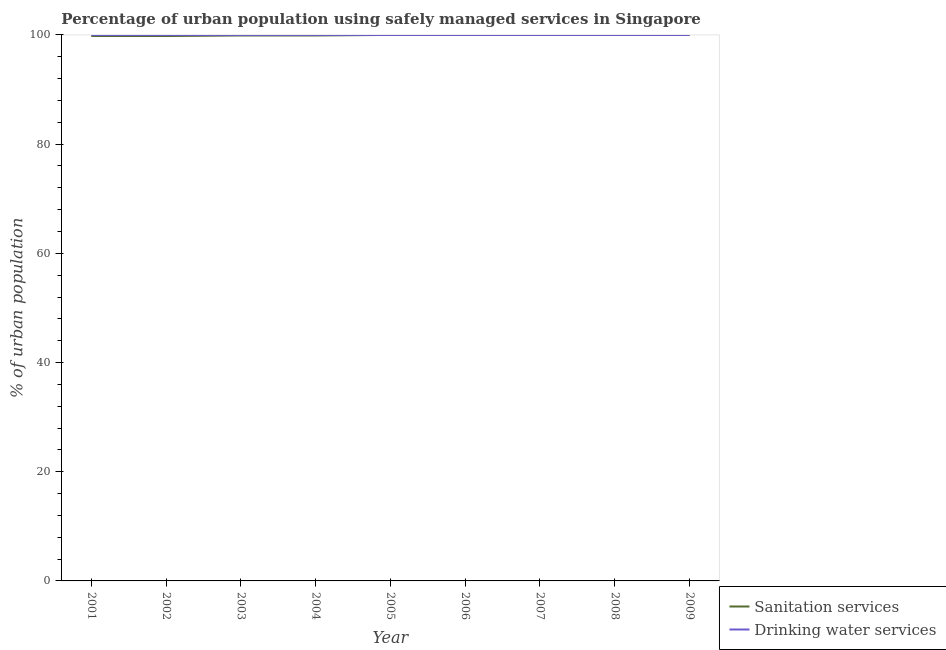How many different coloured lines are there?
Give a very brief answer. 2. Is the number of lines equal to the number of legend labels?
Offer a terse response. Yes. What is the percentage of urban population who used drinking water services in 2001?
Provide a short and direct response. 100. Across all years, what is the maximum percentage of urban population who used drinking water services?
Your answer should be very brief. 100. Across all years, what is the minimum percentage of urban population who used drinking water services?
Keep it short and to the point. 100. What is the total percentage of urban population who used sanitation services in the graph?
Provide a short and direct response. 899.4. What is the difference between the percentage of urban population who used sanitation services in 2004 and that in 2005?
Make the answer very short. -0.1. What is the difference between the percentage of urban population who used drinking water services in 2002 and the percentage of urban population who used sanitation services in 2006?
Keep it short and to the point. 0. What is the average percentage of urban population who used sanitation services per year?
Ensure brevity in your answer.  99.93. In the year 2001, what is the difference between the percentage of urban population who used drinking water services and percentage of urban population who used sanitation services?
Provide a succinct answer. 0.2. In how many years, is the percentage of urban population who used sanitation services greater than 8 %?
Your answer should be very brief. 9. Is the difference between the percentage of urban population who used drinking water services in 2006 and 2009 greater than the difference between the percentage of urban population who used sanitation services in 2006 and 2009?
Offer a terse response. No. What is the difference between the highest and the second highest percentage of urban population who used sanitation services?
Keep it short and to the point. 0. What is the difference between the highest and the lowest percentage of urban population who used sanitation services?
Keep it short and to the point. 0.2. In how many years, is the percentage of urban population who used drinking water services greater than the average percentage of urban population who used drinking water services taken over all years?
Your answer should be compact. 0. Is the sum of the percentage of urban population who used drinking water services in 2004 and 2009 greater than the maximum percentage of urban population who used sanitation services across all years?
Your answer should be very brief. Yes. Does the percentage of urban population who used sanitation services monotonically increase over the years?
Your answer should be very brief. No. Is the percentage of urban population who used drinking water services strictly greater than the percentage of urban population who used sanitation services over the years?
Your answer should be very brief. No. Is the percentage of urban population who used drinking water services strictly less than the percentage of urban population who used sanitation services over the years?
Keep it short and to the point. No. How many years are there in the graph?
Make the answer very short. 9. Are the values on the major ticks of Y-axis written in scientific E-notation?
Provide a succinct answer. No. Does the graph contain any zero values?
Provide a succinct answer. No. What is the title of the graph?
Offer a very short reply. Percentage of urban population using safely managed services in Singapore. What is the label or title of the Y-axis?
Your answer should be compact. % of urban population. What is the % of urban population in Sanitation services in 2001?
Your answer should be very brief. 99.8. What is the % of urban population of Drinking water services in 2001?
Your response must be concise. 100. What is the % of urban population of Sanitation services in 2002?
Your answer should be compact. 99.8. What is the % of urban population in Sanitation services in 2003?
Your answer should be very brief. 99.9. What is the % of urban population of Drinking water services in 2003?
Ensure brevity in your answer.  100. What is the % of urban population of Sanitation services in 2004?
Offer a terse response. 99.9. What is the % of urban population of Drinking water services in 2004?
Offer a terse response. 100. What is the % of urban population of Sanitation services in 2005?
Provide a short and direct response. 100. What is the % of urban population in Drinking water services in 2005?
Give a very brief answer. 100. What is the % of urban population of Sanitation services in 2006?
Give a very brief answer. 100. What is the % of urban population of Drinking water services in 2006?
Keep it short and to the point. 100. What is the % of urban population of Sanitation services in 2007?
Give a very brief answer. 100. What is the % of urban population of Drinking water services in 2007?
Ensure brevity in your answer.  100. What is the % of urban population in Sanitation services in 2008?
Keep it short and to the point. 100. What is the % of urban population in Drinking water services in 2008?
Offer a very short reply. 100. What is the % of urban population of Sanitation services in 2009?
Ensure brevity in your answer.  100. Across all years, what is the minimum % of urban population of Sanitation services?
Offer a terse response. 99.8. Across all years, what is the minimum % of urban population in Drinking water services?
Make the answer very short. 100. What is the total % of urban population of Sanitation services in the graph?
Your response must be concise. 899.4. What is the total % of urban population of Drinking water services in the graph?
Keep it short and to the point. 900. What is the difference between the % of urban population of Drinking water services in 2001 and that in 2002?
Your answer should be very brief. 0. What is the difference between the % of urban population in Sanitation services in 2001 and that in 2003?
Provide a succinct answer. -0.1. What is the difference between the % of urban population in Sanitation services in 2001 and that in 2006?
Ensure brevity in your answer.  -0.2. What is the difference between the % of urban population of Sanitation services in 2001 and that in 2007?
Provide a succinct answer. -0.2. What is the difference between the % of urban population in Drinking water services in 2001 and that in 2007?
Keep it short and to the point. 0. What is the difference between the % of urban population of Sanitation services in 2001 and that in 2008?
Ensure brevity in your answer.  -0.2. What is the difference between the % of urban population of Drinking water services in 2001 and that in 2009?
Ensure brevity in your answer.  0. What is the difference between the % of urban population in Sanitation services in 2002 and that in 2003?
Ensure brevity in your answer.  -0.1. What is the difference between the % of urban population of Drinking water services in 2002 and that in 2003?
Ensure brevity in your answer.  0. What is the difference between the % of urban population of Drinking water services in 2002 and that in 2004?
Offer a terse response. 0. What is the difference between the % of urban population in Sanitation services in 2002 and that in 2005?
Your answer should be very brief. -0.2. What is the difference between the % of urban population of Sanitation services in 2002 and that in 2006?
Make the answer very short. -0.2. What is the difference between the % of urban population in Drinking water services in 2002 and that in 2006?
Offer a terse response. 0. What is the difference between the % of urban population in Sanitation services in 2002 and that in 2007?
Provide a short and direct response. -0.2. What is the difference between the % of urban population in Drinking water services in 2002 and that in 2007?
Offer a terse response. 0. What is the difference between the % of urban population in Sanitation services in 2002 and that in 2008?
Make the answer very short. -0.2. What is the difference between the % of urban population of Drinking water services in 2002 and that in 2008?
Your answer should be very brief. 0. What is the difference between the % of urban population of Sanitation services in 2002 and that in 2009?
Your response must be concise. -0.2. What is the difference between the % of urban population in Drinking water services in 2002 and that in 2009?
Ensure brevity in your answer.  0. What is the difference between the % of urban population in Sanitation services in 2003 and that in 2005?
Offer a terse response. -0.1. What is the difference between the % of urban population in Drinking water services in 2003 and that in 2005?
Your response must be concise. 0. What is the difference between the % of urban population in Drinking water services in 2003 and that in 2007?
Your response must be concise. 0. What is the difference between the % of urban population in Sanitation services in 2003 and that in 2008?
Your response must be concise. -0.1. What is the difference between the % of urban population of Sanitation services in 2003 and that in 2009?
Make the answer very short. -0.1. What is the difference between the % of urban population in Drinking water services in 2003 and that in 2009?
Make the answer very short. 0. What is the difference between the % of urban population in Drinking water services in 2004 and that in 2005?
Your answer should be very brief. 0. What is the difference between the % of urban population in Drinking water services in 2004 and that in 2006?
Give a very brief answer. 0. What is the difference between the % of urban population in Sanitation services in 2004 and that in 2007?
Keep it short and to the point. -0.1. What is the difference between the % of urban population in Drinking water services in 2004 and that in 2008?
Provide a short and direct response. 0. What is the difference between the % of urban population in Drinking water services in 2004 and that in 2009?
Your answer should be compact. 0. What is the difference between the % of urban population in Sanitation services in 2005 and that in 2009?
Offer a terse response. 0. What is the difference between the % of urban population of Drinking water services in 2006 and that in 2008?
Give a very brief answer. 0. What is the difference between the % of urban population in Sanitation services in 2006 and that in 2009?
Your answer should be very brief. 0. What is the difference between the % of urban population of Drinking water services in 2006 and that in 2009?
Keep it short and to the point. 0. What is the difference between the % of urban population in Sanitation services in 2007 and that in 2009?
Ensure brevity in your answer.  0. What is the difference between the % of urban population of Sanitation services in 2008 and that in 2009?
Keep it short and to the point. 0. What is the difference between the % of urban population of Sanitation services in 2001 and the % of urban population of Drinking water services in 2002?
Provide a short and direct response. -0.2. What is the difference between the % of urban population of Sanitation services in 2001 and the % of urban population of Drinking water services in 2005?
Your answer should be compact. -0.2. What is the difference between the % of urban population in Sanitation services in 2001 and the % of urban population in Drinking water services in 2008?
Your answer should be very brief. -0.2. What is the difference between the % of urban population of Sanitation services in 2002 and the % of urban population of Drinking water services in 2003?
Offer a terse response. -0.2. What is the difference between the % of urban population in Sanitation services in 2002 and the % of urban population in Drinking water services in 2006?
Your answer should be very brief. -0.2. What is the difference between the % of urban population in Sanitation services in 2002 and the % of urban population in Drinking water services in 2007?
Your response must be concise. -0.2. What is the difference between the % of urban population of Sanitation services in 2003 and the % of urban population of Drinking water services in 2005?
Offer a terse response. -0.1. What is the difference between the % of urban population in Sanitation services in 2003 and the % of urban population in Drinking water services in 2006?
Your answer should be very brief. -0.1. What is the difference between the % of urban population of Sanitation services in 2003 and the % of urban population of Drinking water services in 2008?
Provide a succinct answer. -0.1. What is the difference between the % of urban population of Sanitation services in 2003 and the % of urban population of Drinking water services in 2009?
Keep it short and to the point. -0.1. What is the difference between the % of urban population of Sanitation services in 2004 and the % of urban population of Drinking water services in 2005?
Offer a terse response. -0.1. What is the difference between the % of urban population in Sanitation services in 2004 and the % of urban population in Drinking water services in 2006?
Provide a short and direct response. -0.1. What is the difference between the % of urban population of Sanitation services in 2004 and the % of urban population of Drinking water services in 2008?
Your response must be concise. -0.1. What is the difference between the % of urban population in Sanitation services in 2005 and the % of urban population in Drinking water services in 2007?
Your response must be concise. 0. What is the difference between the % of urban population of Sanitation services in 2005 and the % of urban population of Drinking water services in 2008?
Provide a succinct answer. 0. What is the difference between the % of urban population in Sanitation services in 2006 and the % of urban population in Drinking water services in 2008?
Your answer should be very brief. 0. What is the difference between the % of urban population of Sanitation services in 2006 and the % of urban population of Drinking water services in 2009?
Provide a short and direct response. 0. What is the difference between the % of urban population in Sanitation services in 2008 and the % of urban population in Drinking water services in 2009?
Give a very brief answer. 0. What is the average % of urban population in Sanitation services per year?
Keep it short and to the point. 99.93. What is the average % of urban population in Drinking water services per year?
Your answer should be very brief. 100. In the year 2001, what is the difference between the % of urban population in Sanitation services and % of urban population in Drinking water services?
Offer a very short reply. -0.2. In the year 2002, what is the difference between the % of urban population in Sanitation services and % of urban population in Drinking water services?
Ensure brevity in your answer.  -0.2. In the year 2003, what is the difference between the % of urban population in Sanitation services and % of urban population in Drinking water services?
Provide a succinct answer. -0.1. In the year 2005, what is the difference between the % of urban population of Sanitation services and % of urban population of Drinking water services?
Offer a terse response. 0. In the year 2007, what is the difference between the % of urban population of Sanitation services and % of urban population of Drinking water services?
Provide a short and direct response. 0. In the year 2008, what is the difference between the % of urban population of Sanitation services and % of urban population of Drinking water services?
Offer a very short reply. 0. What is the ratio of the % of urban population of Sanitation services in 2001 to that in 2003?
Provide a succinct answer. 1. What is the ratio of the % of urban population of Sanitation services in 2001 to that in 2006?
Offer a terse response. 1. What is the ratio of the % of urban population in Sanitation services in 2001 to that in 2007?
Ensure brevity in your answer.  1. What is the ratio of the % of urban population of Sanitation services in 2001 to that in 2009?
Make the answer very short. 1. What is the ratio of the % of urban population in Drinking water services in 2002 to that in 2003?
Provide a succinct answer. 1. What is the ratio of the % of urban population in Sanitation services in 2002 to that in 2004?
Offer a very short reply. 1. What is the ratio of the % of urban population of Drinking water services in 2002 to that in 2004?
Keep it short and to the point. 1. What is the ratio of the % of urban population of Sanitation services in 2002 to that in 2005?
Make the answer very short. 1. What is the ratio of the % of urban population of Drinking water services in 2002 to that in 2005?
Provide a short and direct response. 1. What is the ratio of the % of urban population in Sanitation services in 2002 to that in 2006?
Make the answer very short. 1. What is the ratio of the % of urban population of Drinking water services in 2002 to that in 2006?
Provide a succinct answer. 1. What is the ratio of the % of urban population in Sanitation services in 2002 to that in 2007?
Keep it short and to the point. 1. What is the ratio of the % of urban population of Sanitation services in 2002 to that in 2008?
Ensure brevity in your answer.  1. What is the ratio of the % of urban population of Drinking water services in 2002 to that in 2008?
Provide a succinct answer. 1. What is the ratio of the % of urban population in Drinking water services in 2002 to that in 2009?
Your answer should be compact. 1. What is the ratio of the % of urban population of Sanitation services in 2003 to that in 2004?
Keep it short and to the point. 1. What is the ratio of the % of urban population of Drinking water services in 2003 to that in 2004?
Provide a succinct answer. 1. What is the ratio of the % of urban population in Drinking water services in 2003 to that in 2005?
Give a very brief answer. 1. What is the ratio of the % of urban population of Drinking water services in 2003 to that in 2006?
Give a very brief answer. 1. What is the ratio of the % of urban population in Sanitation services in 2003 to that in 2007?
Provide a short and direct response. 1. What is the ratio of the % of urban population of Sanitation services in 2003 to that in 2008?
Keep it short and to the point. 1. What is the ratio of the % of urban population in Sanitation services in 2003 to that in 2009?
Offer a terse response. 1. What is the ratio of the % of urban population of Drinking water services in 2003 to that in 2009?
Offer a very short reply. 1. What is the ratio of the % of urban population in Drinking water services in 2004 to that in 2005?
Offer a very short reply. 1. What is the ratio of the % of urban population of Sanitation services in 2004 to that in 2006?
Offer a very short reply. 1. What is the ratio of the % of urban population of Sanitation services in 2004 to that in 2008?
Your answer should be compact. 1. What is the ratio of the % of urban population of Drinking water services in 2004 to that in 2008?
Give a very brief answer. 1. What is the ratio of the % of urban population of Sanitation services in 2004 to that in 2009?
Keep it short and to the point. 1. What is the ratio of the % of urban population of Sanitation services in 2005 to that in 2007?
Keep it short and to the point. 1. What is the ratio of the % of urban population of Sanitation services in 2005 to that in 2009?
Offer a very short reply. 1. What is the ratio of the % of urban population in Drinking water services in 2006 to that in 2007?
Make the answer very short. 1. What is the ratio of the % of urban population of Sanitation services in 2007 to that in 2008?
Keep it short and to the point. 1. What is the ratio of the % of urban population of Drinking water services in 2007 to that in 2009?
Your answer should be very brief. 1. What is the ratio of the % of urban population in Sanitation services in 2008 to that in 2009?
Give a very brief answer. 1. What is the difference between the highest and the second highest % of urban population in Drinking water services?
Provide a succinct answer. 0. What is the difference between the highest and the lowest % of urban population in Sanitation services?
Your answer should be compact. 0.2. What is the difference between the highest and the lowest % of urban population of Drinking water services?
Keep it short and to the point. 0. 